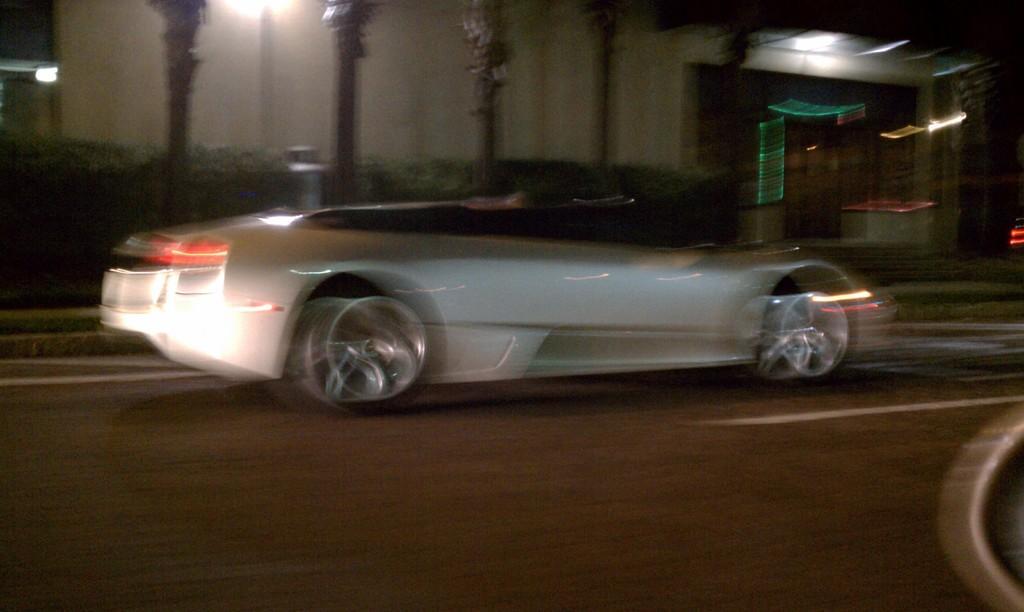In one or two sentences, can you explain what this image depicts? In this picture I can see a vehicle on the road, there are plants, trees and a building. 